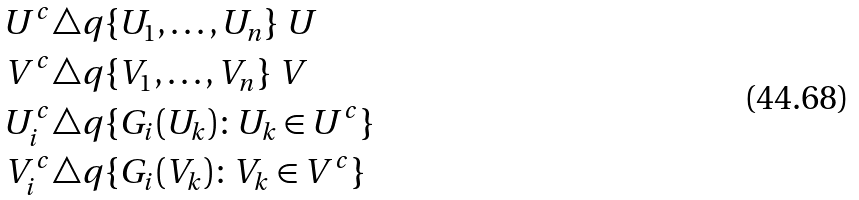Convert formula to latex. <formula><loc_0><loc_0><loc_500><loc_500>U ^ { c } & \triangle q \{ U _ { 1 } , \dots , U _ { n } \} \ U \\ V ^ { c } & \triangle q \{ V _ { 1 } , \dots , V _ { n } \} \ V \\ U ^ { c } _ { i } & \triangle q \{ G _ { i } ( U _ { k } ) \colon U _ { k } \in U ^ { c } \} \\ V ^ { c } _ { i } & \triangle q \{ G _ { i } ( V _ { k } ) \colon V _ { k } \in V ^ { c } \}</formula> 